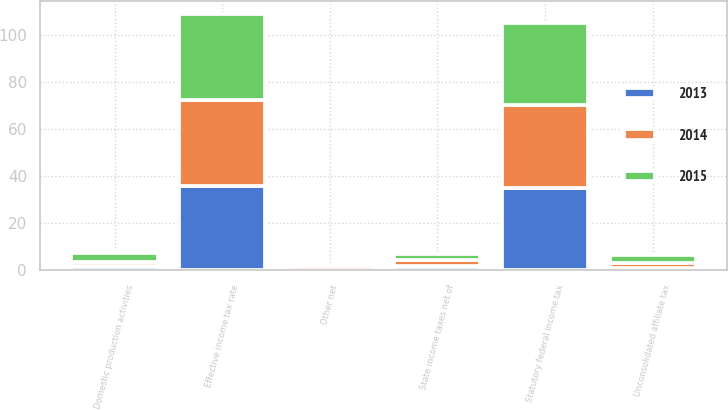Convert chart. <chart><loc_0><loc_0><loc_500><loc_500><stacked_bar_chart><ecel><fcel>Statutory federal income tax<fcel>State income taxes net of<fcel>Unconsolidated affiliate tax<fcel>Domestic production activities<fcel>Other net<fcel>Effective income tax rate<nl><fcel>2013<fcel>35<fcel>1.8<fcel>1.1<fcel>2.1<fcel>0.1<fcel>35.7<nl><fcel>2015<fcel>35<fcel>2.6<fcel>3.4<fcel>4.1<fcel>0.3<fcel>36.6<nl><fcel>2014<fcel>35<fcel>2.5<fcel>1.9<fcel>1.3<fcel>1.6<fcel>36.5<nl></chart> 